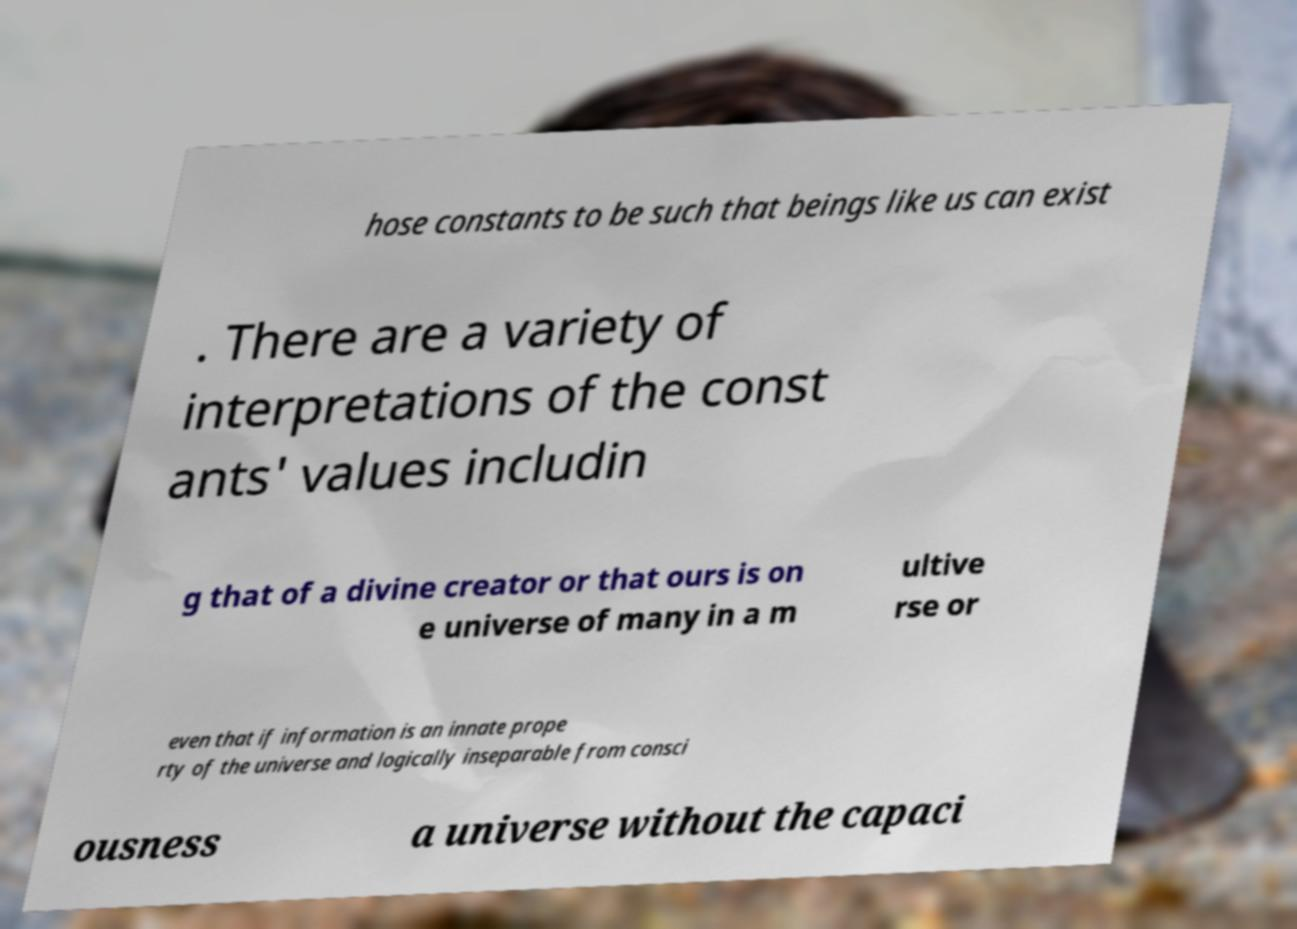I need the written content from this picture converted into text. Can you do that? hose constants to be such that beings like us can exist . There are a variety of interpretations of the const ants' values includin g that of a divine creator or that ours is on e universe of many in a m ultive rse or even that if information is an innate prope rty of the universe and logically inseparable from consci ousness a universe without the capaci 